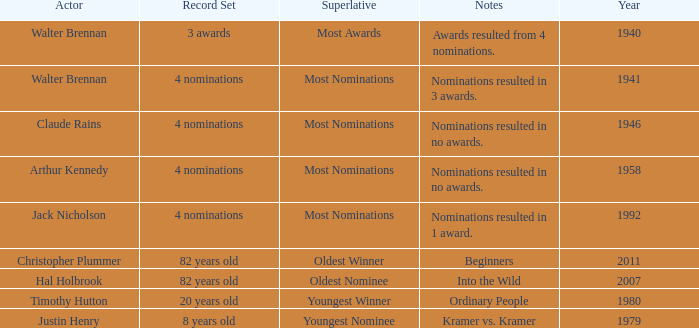What is the earliest year for ordinary people to appear in the notes? 1980.0. 